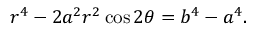Convert formula to latex. <formula><loc_0><loc_0><loc_500><loc_500>r ^ { 4 } - 2 a ^ { 2 } r ^ { 2 } \cos 2 \theta = b ^ { 4 } - a ^ { 4 } .</formula> 